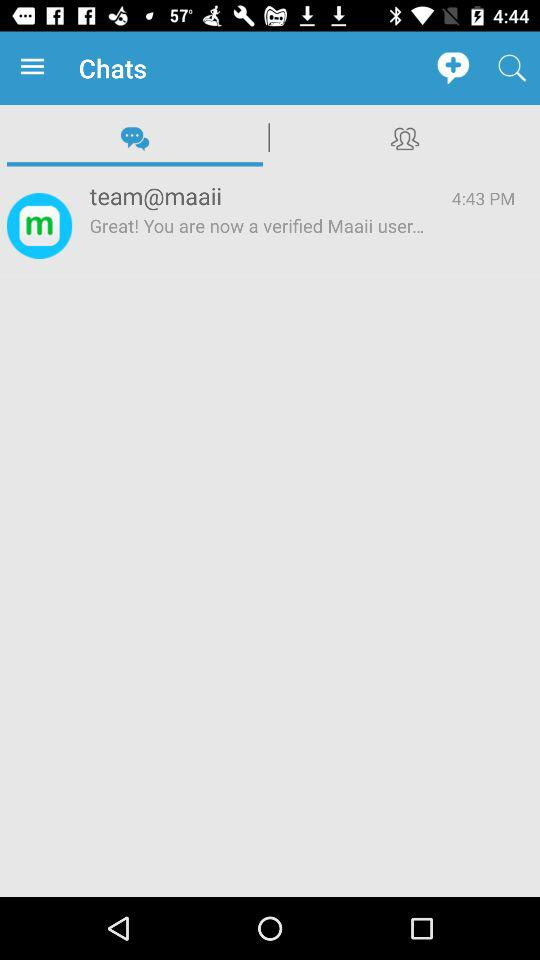What is a given ID? The given ID is team@maaii. 